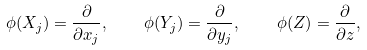<formula> <loc_0><loc_0><loc_500><loc_500>\phi ( X _ { j } ) = \frac { \partial } { \partial x _ { j } } , \quad \phi ( Y _ { j } ) = \frac { \partial } { \partial y _ { j } } , \quad \phi ( Z ) = \frac { \partial } { \partial z } ,</formula> 